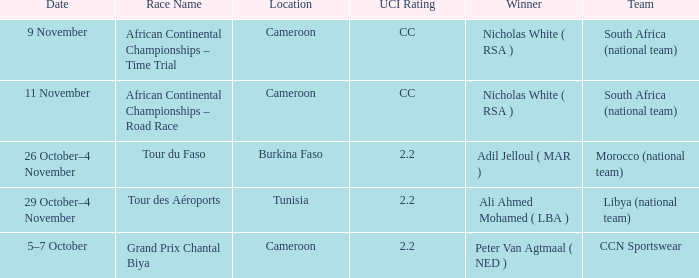Who is the winner of the race in Burkina Faso? Adil Jelloul ( MAR ). 